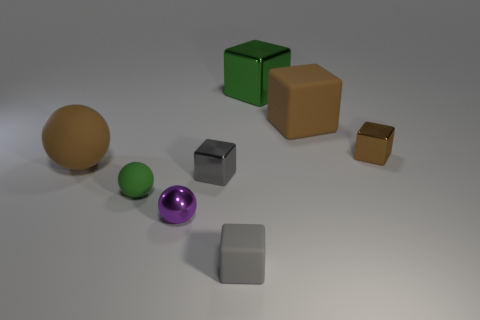What is the size of the metal thing that is the same color as the large rubber block?
Offer a terse response. Small. Are there any tiny gray metal things that have the same shape as the small gray matte object?
Provide a succinct answer. Yes. There is a shiny thing on the right side of the big shiny thing; is it the same size as the brown object that is on the left side of the green shiny thing?
Offer a very short reply. No. Are there fewer small brown shiny blocks behind the green shiny thing than small gray metal things that are in front of the large sphere?
Keep it short and to the point. Yes. There is a small cube that is the same color as the big sphere; what is it made of?
Provide a succinct answer. Metal. There is a tiny block in front of the gray metal thing; what is its color?
Ensure brevity in your answer.  Gray. Do the large shiny cube and the small rubber ball have the same color?
Your response must be concise. Yes. What number of large objects are in front of the tiny metal block on the left side of the tiny metal thing right of the big metallic cube?
Provide a short and direct response. 0. The green metal thing is what size?
Your answer should be compact. Large. There is a brown block that is the same size as the green rubber thing; what is its material?
Your answer should be compact. Metal. 